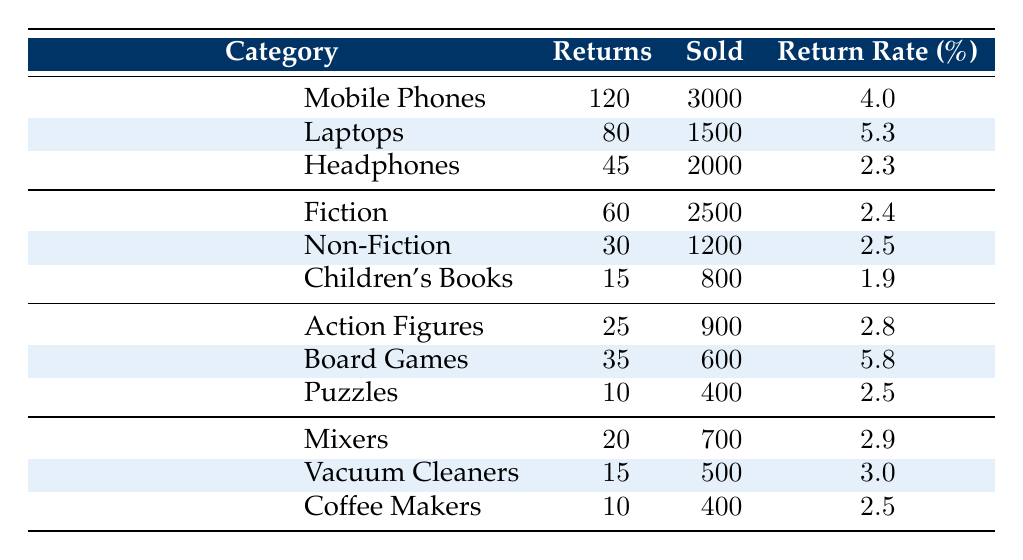What is the return rate for laptops? The return rate for laptops can be found directly in the Electronics category under Laptops, which states the return rate is 5.3%.
Answer: 5.3 Which product category had the highest return rate? To find the product category with the highest return rate, we compare the return rates listed in all categories. The return rate for Laptops is 5.3%, for Board Games is 5.8%, and for others it is lower. Board Games has the highest return rate.
Answer: Board Games How many more returns did mobile phones have compared to headphone returns? The number of returns for mobile phones is 120, and the returns for headphones is 45. To find the difference: 120 - 45 = 75. Therefore, mobile phones had 75 more returns than headphones.
Answer: 75 What is the total return rate for all categories combined? To find the overall return rate, we need to calculate the total returns and total sold across all categories. The total returns are 120 + 80 + 45 + 60 + 30 + 15 + 25 + 35 + 10 + 20 + 15 + 10 =  450 and the total sold is 3000 + 1500 + 2000 + 2500 + 1200 + 800 + 900 + 600 + 400 + 700 + 500 + 400 =  12300. The overall return rate is (450 / 12300) * 100 = 3.65%.
Answer: 3.65 Is the return rate for children's books higher than that of coffee makers? The return rate for children's books is 1.9%, while for coffee makers it is 2.5%. Since 1.9% is less than 2.5%, the return rate for children's books is not higher than that for coffee makers.
Answer: No Which category had the least number of returns and what was the rate? To identify the category with the least number of returns, we check the returns for each category: Electronics (245), Books (105), Toys (70), and Home Appliances (45). Home Appliances had the least returns with 45 total. The return rate for this category is 2.5%.
Answer: Home Appliances, 2.5 